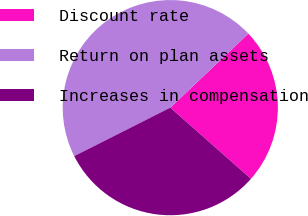<chart> <loc_0><loc_0><loc_500><loc_500><pie_chart><fcel>Discount rate<fcel>Return on plan assets<fcel>Increases in compensation<nl><fcel>23.59%<fcel>45.36%<fcel>31.05%<nl></chart> 